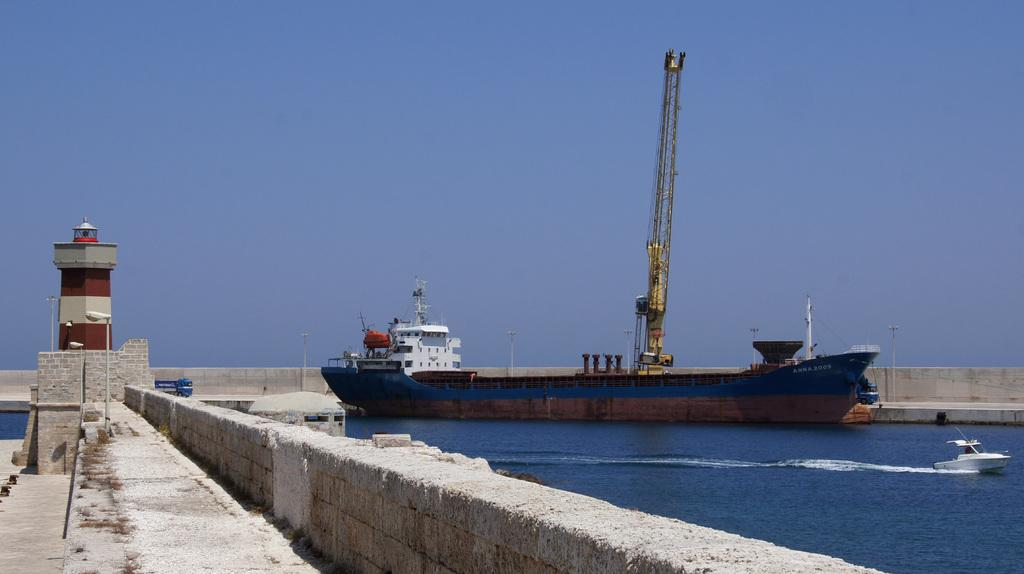What type of vehicles are present in the image? There are two ships in the image, a huge ship and a small ship. Where are the ships located in the image? Both ships are on the water surface in the image. What is the background of the image? There is a wall beside the water surface, and a lighthouse is behind the wall. What type of stamp can be seen on the small ship in the image? There is no stamp visible on either ship in the image. Can you smell the popcorn being served on the huge ship in the image? There is no mention of popcorn or any food in the image; it only features the ships and their surroundings. 